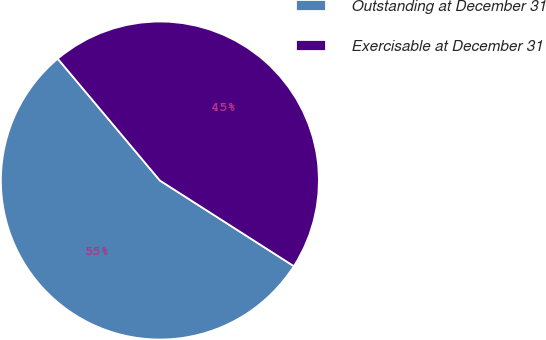<chart> <loc_0><loc_0><loc_500><loc_500><pie_chart><fcel>Outstanding at December 31<fcel>Exercisable at December 31<nl><fcel>54.84%<fcel>45.16%<nl></chart> 